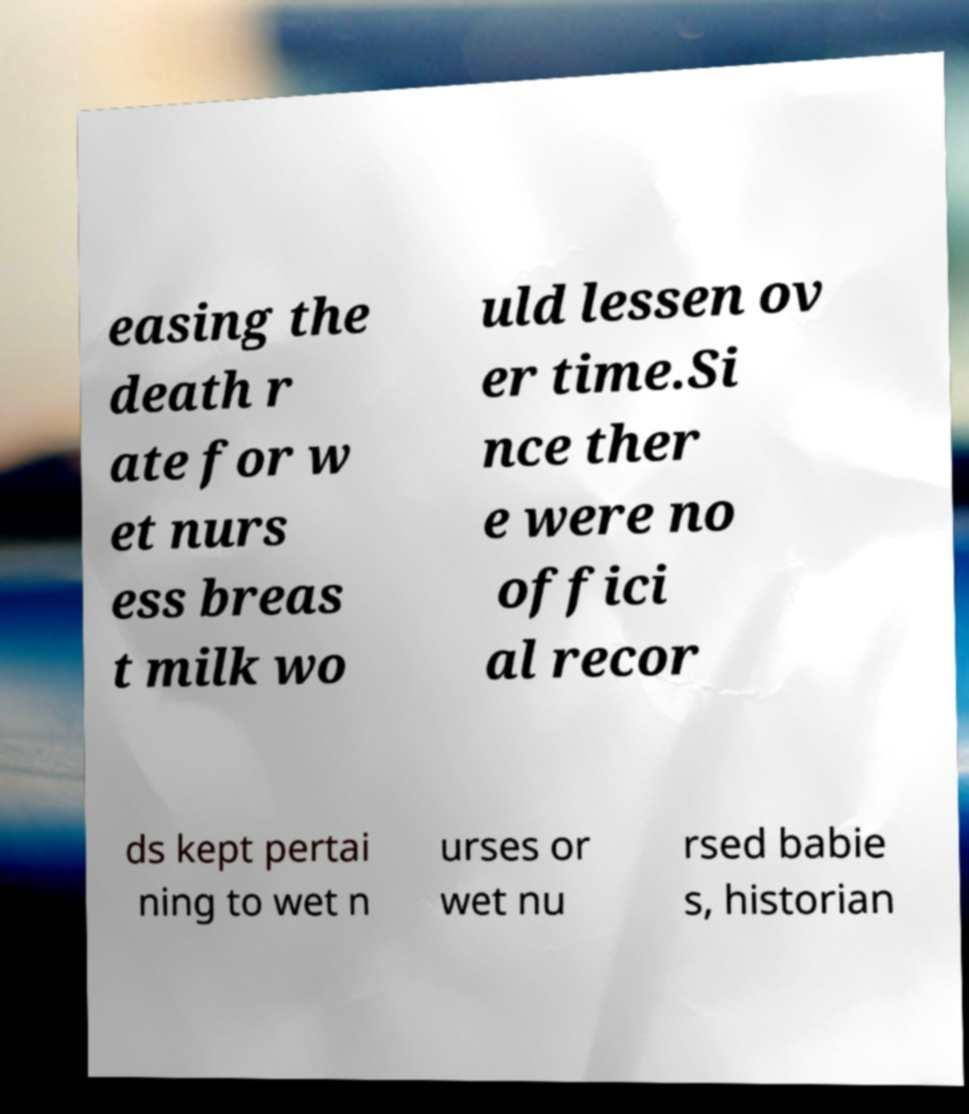Please identify and transcribe the text found in this image. easing the death r ate for w et nurs ess breas t milk wo uld lessen ov er time.Si nce ther e were no offici al recor ds kept pertai ning to wet n urses or wet nu rsed babie s, historian 